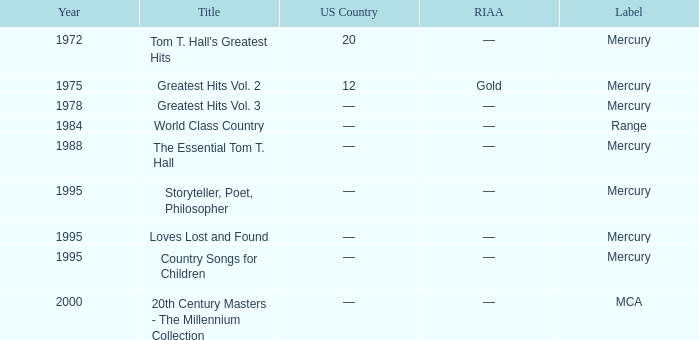What is the highest year for the title, "loves lost and found"? 1995.0. 